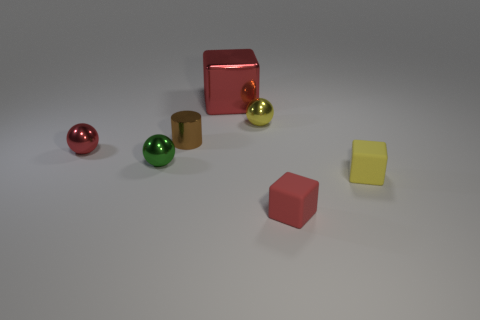There is a red object that is in front of the tiny red shiny object; what size is it?
Make the answer very short. Small. How many tiny cubes have the same color as the large cube?
Your answer should be compact. 1. How many balls are either small blue shiny things or yellow metallic things?
Your answer should be compact. 1. There is a shiny thing that is both on the left side of the yellow ball and behind the tiny cylinder; what shape is it?
Ensure brevity in your answer.  Cube. Are there any spheres of the same size as the brown metallic thing?
Keep it short and to the point. Yes. How many things are tiny things on the left side of the big metal object or green cylinders?
Give a very brief answer. 3. Does the big object have the same material as the yellow thing on the left side of the yellow cube?
Provide a short and direct response. Yes. How many other things are there of the same shape as the red rubber thing?
Provide a succinct answer. 2. How many things are things in front of the tiny green shiny thing or tiny objects in front of the red shiny ball?
Keep it short and to the point. 3. What number of other objects are there of the same color as the large shiny block?
Your answer should be very brief. 2. 